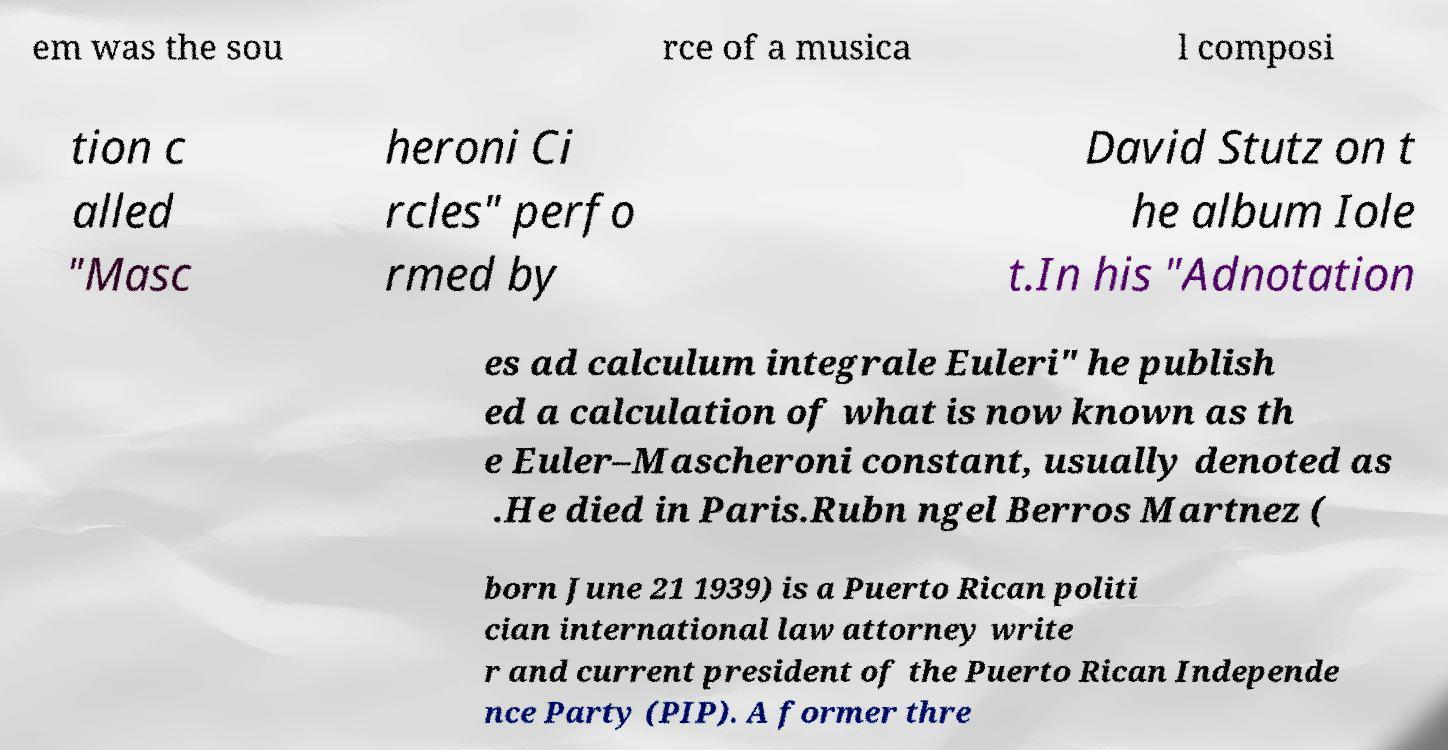Could you assist in decoding the text presented in this image and type it out clearly? em was the sou rce of a musica l composi tion c alled "Masc heroni Ci rcles" perfo rmed by David Stutz on t he album Iole t.In his "Adnotation es ad calculum integrale Euleri" he publish ed a calculation of what is now known as th e Euler–Mascheroni constant, usually denoted as .He died in Paris.Rubn ngel Berros Martnez ( born June 21 1939) is a Puerto Rican politi cian international law attorney write r and current president of the Puerto Rican Independe nce Party (PIP). A former thre 